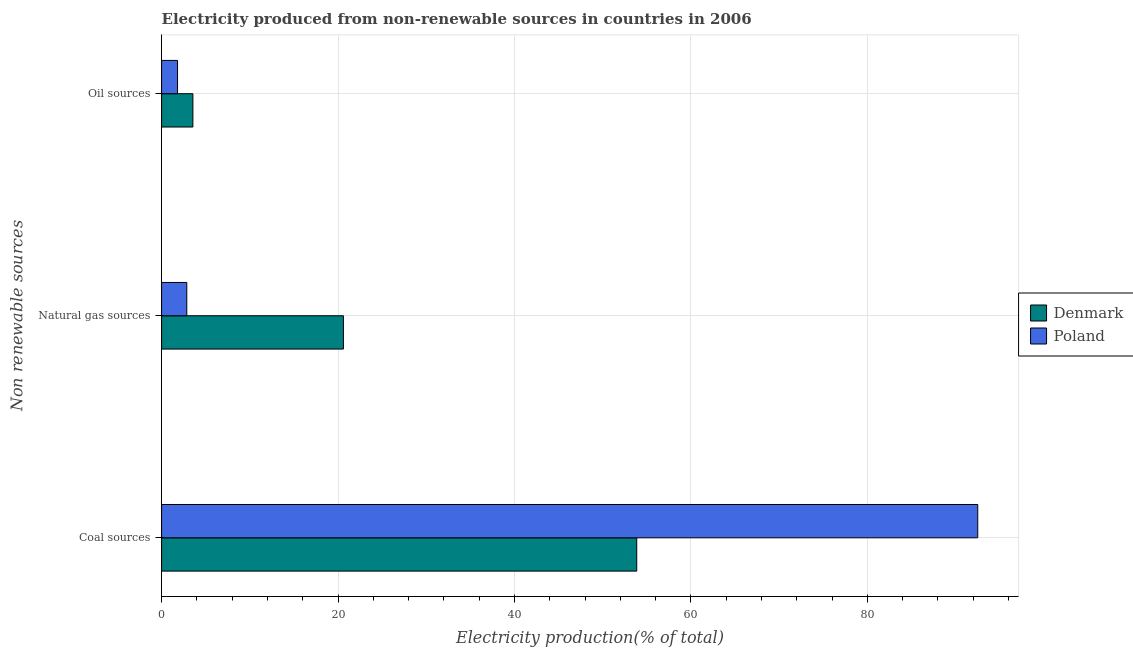How many groups of bars are there?
Offer a very short reply. 3. Are the number of bars per tick equal to the number of legend labels?
Provide a succinct answer. Yes. Are the number of bars on each tick of the Y-axis equal?
Your answer should be compact. Yes. How many bars are there on the 1st tick from the top?
Offer a very short reply. 2. What is the label of the 2nd group of bars from the top?
Your answer should be compact. Natural gas sources. What is the percentage of electricity produced by oil sources in Denmark?
Offer a very short reply. 3.55. Across all countries, what is the maximum percentage of electricity produced by oil sources?
Offer a terse response. 3.55. Across all countries, what is the minimum percentage of electricity produced by oil sources?
Keep it short and to the point. 1.81. In which country was the percentage of electricity produced by natural gas maximum?
Your response must be concise. Denmark. In which country was the percentage of electricity produced by oil sources minimum?
Provide a succinct answer. Poland. What is the total percentage of electricity produced by coal in the graph?
Offer a very short reply. 146.37. What is the difference between the percentage of electricity produced by natural gas in Denmark and that in Poland?
Offer a terse response. 17.75. What is the difference between the percentage of electricity produced by oil sources in Denmark and the percentage of electricity produced by coal in Poland?
Keep it short and to the point. -88.97. What is the average percentage of electricity produced by natural gas per country?
Your response must be concise. 11.74. What is the difference between the percentage of electricity produced by natural gas and percentage of electricity produced by oil sources in Poland?
Offer a terse response. 1.05. What is the ratio of the percentage of electricity produced by natural gas in Poland to that in Denmark?
Provide a succinct answer. 0.14. Is the percentage of electricity produced by oil sources in Denmark less than that in Poland?
Provide a succinct answer. No. What is the difference between the highest and the second highest percentage of electricity produced by coal?
Ensure brevity in your answer.  38.66. What is the difference between the highest and the lowest percentage of electricity produced by oil sources?
Your response must be concise. 1.74. What does the 1st bar from the bottom in Coal sources represents?
Ensure brevity in your answer.  Denmark. Is it the case that in every country, the sum of the percentage of electricity produced by coal and percentage of electricity produced by natural gas is greater than the percentage of electricity produced by oil sources?
Provide a short and direct response. Yes. Are all the bars in the graph horizontal?
Offer a terse response. Yes. How many countries are there in the graph?
Your answer should be very brief. 2. What is the difference between two consecutive major ticks on the X-axis?
Offer a terse response. 20. Does the graph contain grids?
Your response must be concise. Yes. Where does the legend appear in the graph?
Provide a succinct answer. Center right. How many legend labels are there?
Give a very brief answer. 2. What is the title of the graph?
Your answer should be compact. Electricity produced from non-renewable sources in countries in 2006. Does "Australia" appear as one of the legend labels in the graph?
Provide a succinct answer. No. What is the label or title of the Y-axis?
Offer a terse response. Non renewable sources. What is the Electricity production(% of total) in Denmark in Coal sources?
Keep it short and to the point. 53.86. What is the Electricity production(% of total) of Poland in Coal sources?
Offer a very short reply. 92.52. What is the Electricity production(% of total) of Denmark in Natural gas sources?
Offer a terse response. 20.61. What is the Electricity production(% of total) of Poland in Natural gas sources?
Keep it short and to the point. 2.86. What is the Electricity production(% of total) of Denmark in Oil sources?
Keep it short and to the point. 3.55. What is the Electricity production(% of total) in Poland in Oil sources?
Offer a terse response. 1.81. Across all Non renewable sources, what is the maximum Electricity production(% of total) in Denmark?
Offer a terse response. 53.86. Across all Non renewable sources, what is the maximum Electricity production(% of total) of Poland?
Ensure brevity in your answer.  92.52. Across all Non renewable sources, what is the minimum Electricity production(% of total) of Denmark?
Provide a succinct answer. 3.55. Across all Non renewable sources, what is the minimum Electricity production(% of total) of Poland?
Provide a short and direct response. 1.81. What is the total Electricity production(% of total) in Denmark in the graph?
Keep it short and to the point. 78.02. What is the total Electricity production(% of total) of Poland in the graph?
Keep it short and to the point. 97.18. What is the difference between the Electricity production(% of total) of Denmark in Coal sources and that in Natural gas sources?
Give a very brief answer. 33.25. What is the difference between the Electricity production(% of total) in Poland in Coal sources and that in Natural gas sources?
Your answer should be very brief. 89.66. What is the difference between the Electricity production(% of total) of Denmark in Coal sources and that in Oil sources?
Ensure brevity in your answer.  50.31. What is the difference between the Electricity production(% of total) of Poland in Coal sources and that in Oil sources?
Keep it short and to the point. 90.71. What is the difference between the Electricity production(% of total) in Denmark in Natural gas sources and that in Oil sources?
Make the answer very short. 17.06. What is the difference between the Electricity production(% of total) of Denmark in Coal sources and the Electricity production(% of total) of Poland in Natural gas sources?
Make the answer very short. 51. What is the difference between the Electricity production(% of total) of Denmark in Coal sources and the Electricity production(% of total) of Poland in Oil sources?
Provide a short and direct response. 52.05. What is the difference between the Electricity production(% of total) of Denmark in Natural gas sources and the Electricity production(% of total) of Poland in Oil sources?
Your answer should be very brief. 18.8. What is the average Electricity production(% of total) of Denmark per Non renewable sources?
Your answer should be very brief. 26.01. What is the average Electricity production(% of total) in Poland per Non renewable sources?
Provide a short and direct response. 32.39. What is the difference between the Electricity production(% of total) in Denmark and Electricity production(% of total) in Poland in Coal sources?
Give a very brief answer. -38.66. What is the difference between the Electricity production(% of total) of Denmark and Electricity production(% of total) of Poland in Natural gas sources?
Make the answer very short. 17.75. What is the difference between the Electricity production(% of total) of Denmark and Electricity production(% of total) of Poland in Oil sources?
Keep it short and to the point. 1.74. What is the ratio of the Electricity production(% of total) of Denmark in Coal sources to that in Natural gas sources?
Offer a terse response. 2.61. What is the ratio of the Electricity production(% of total) of Poland in Coal sources to that in Natural gas sources?
Give a very brief answer. 32.35. What is the ratio of the Electricity production(% of total) in Denmark in Coal sources to that in Oil sources?
Your answer should be very brief. 15.17. What is the ratio of the Electricity production(% of total) of Poland in Coal sources to that in Oil sources?
Your answer should be compact. 51.13. What is the ratio of the Electricity production(% of total) in Denmark in Natural gas sources to that in Oil sources?
Offer a terse response. 5.81. What is the ratio of the Electricity production(% of total) of Poland in Natural gas sources to that in Oil sources?
Keep it short and to the point. 1.58. What is the difference between the highest and the second highest Electricity production(% of total) in Denmark?
Keep it short and to the point. 33.25. What is the difference between the highest and the second highest Electricity production(% of total) of Poland?
Your response must be concise. 89.66. What is the difference between the highest and the lowest Electricity production(% of total) of Denmark?
Offer a terse response. 50.31. What is the difference between the highest and the lowest Electricity production(% of total) of Poland?
Your response must be concise. 90.71. 